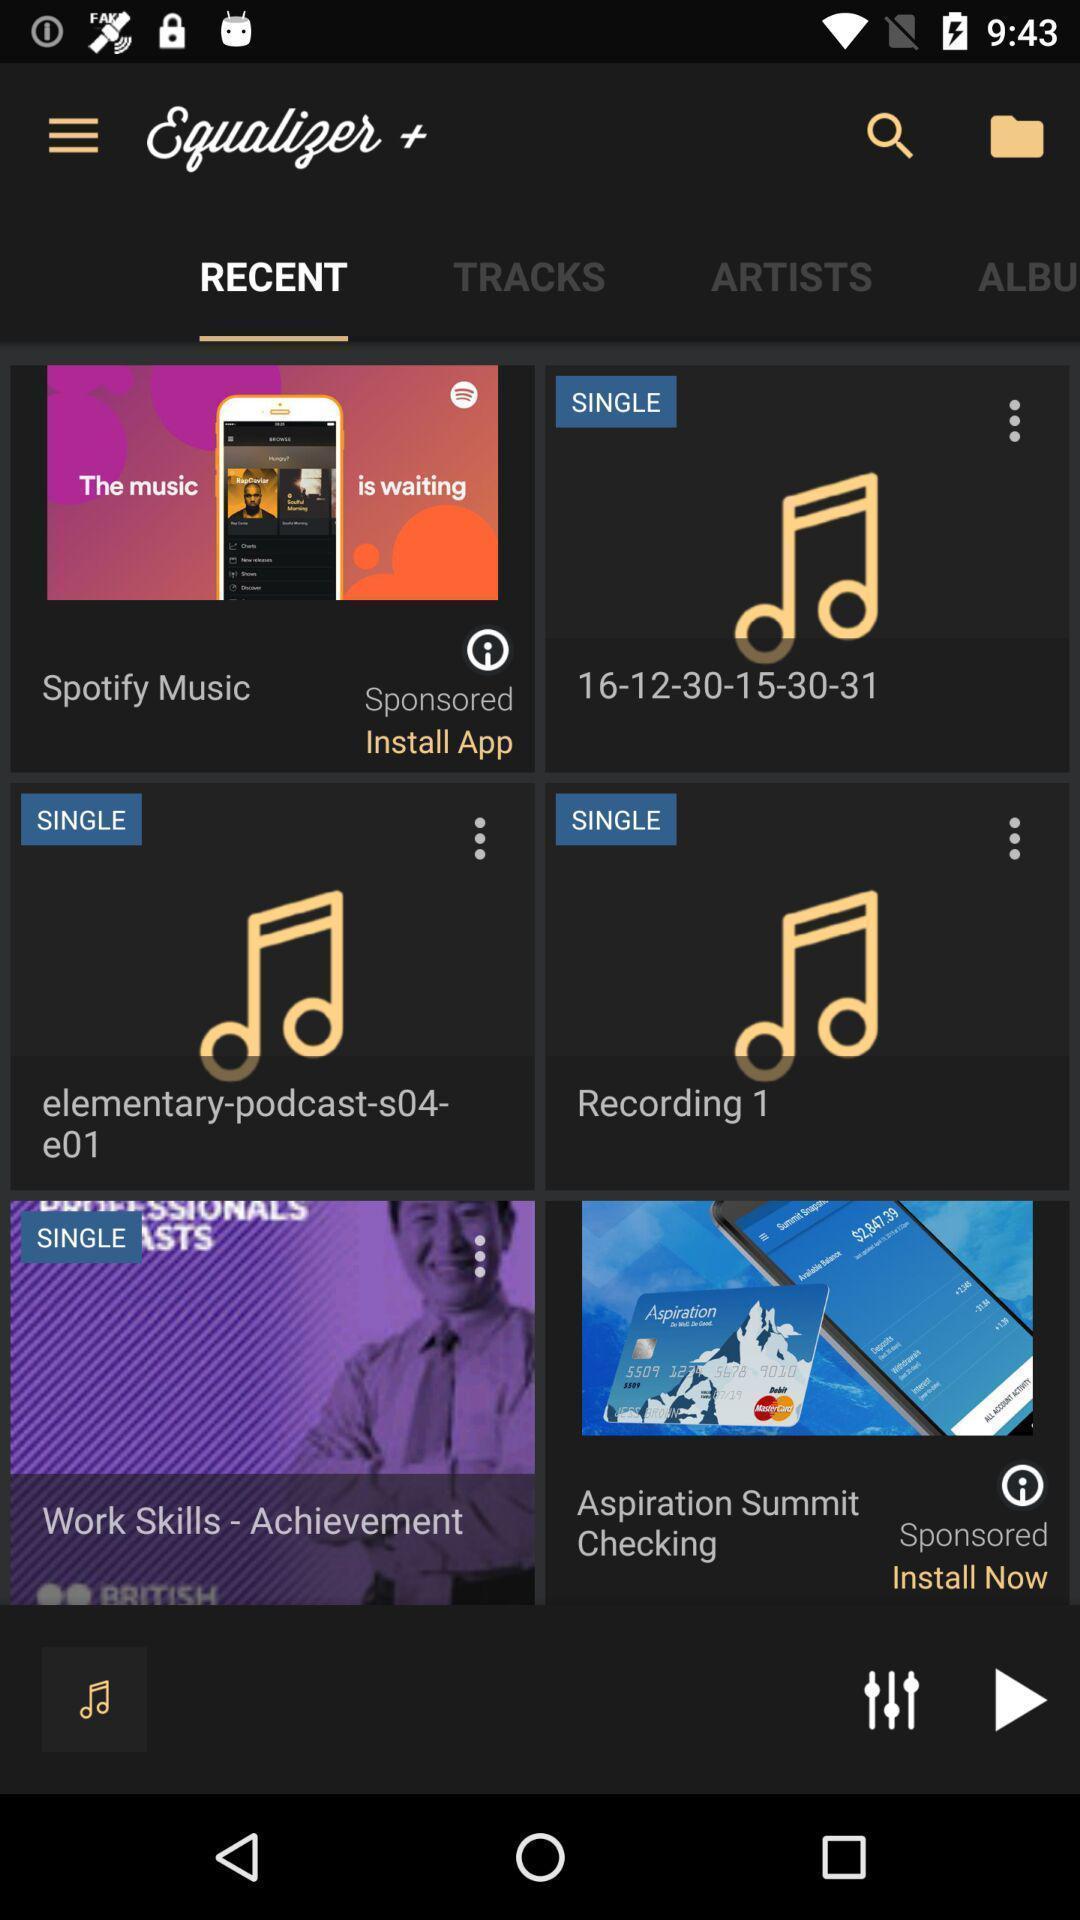Please provide a description for this image. Page displays recent songs in music app. 